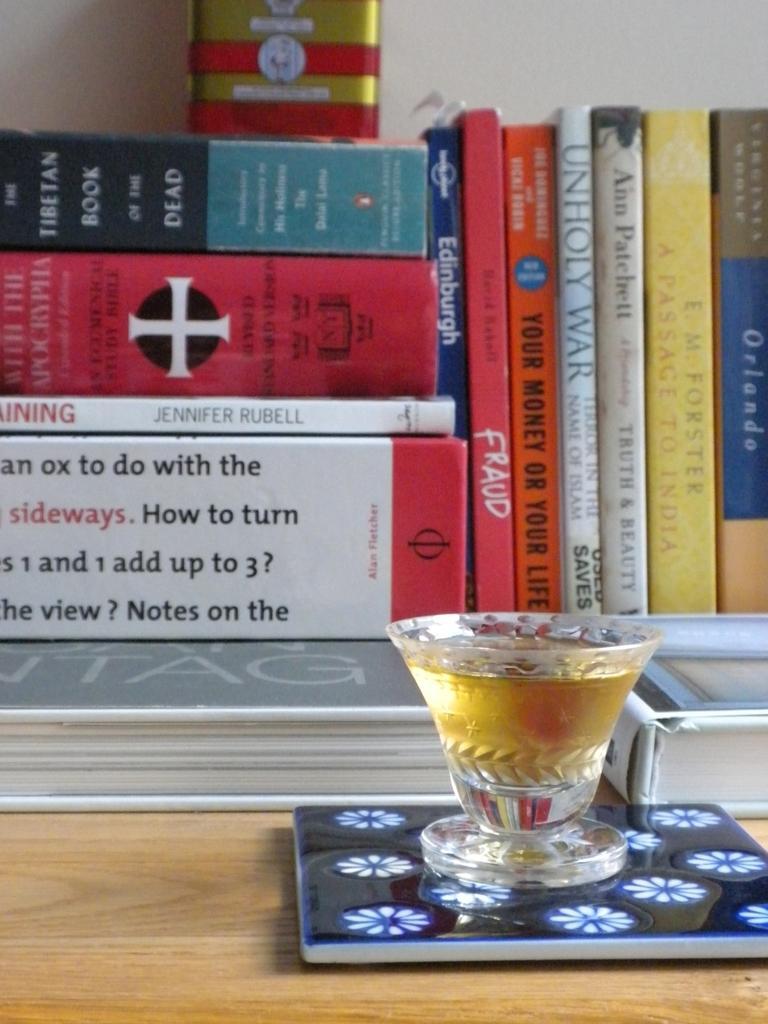Can you describe this image briefly? In this picture we can see lot of books, and a bunch of books here, and here is the table and a glass with some liquid in it. 